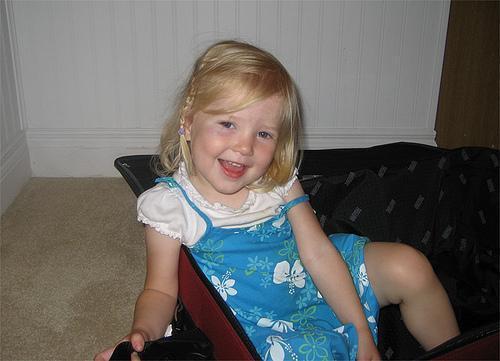How many people are shown?
Give a very brief answer. 1. How many braids does the little girl have?
Give a very brief answer. 1. 